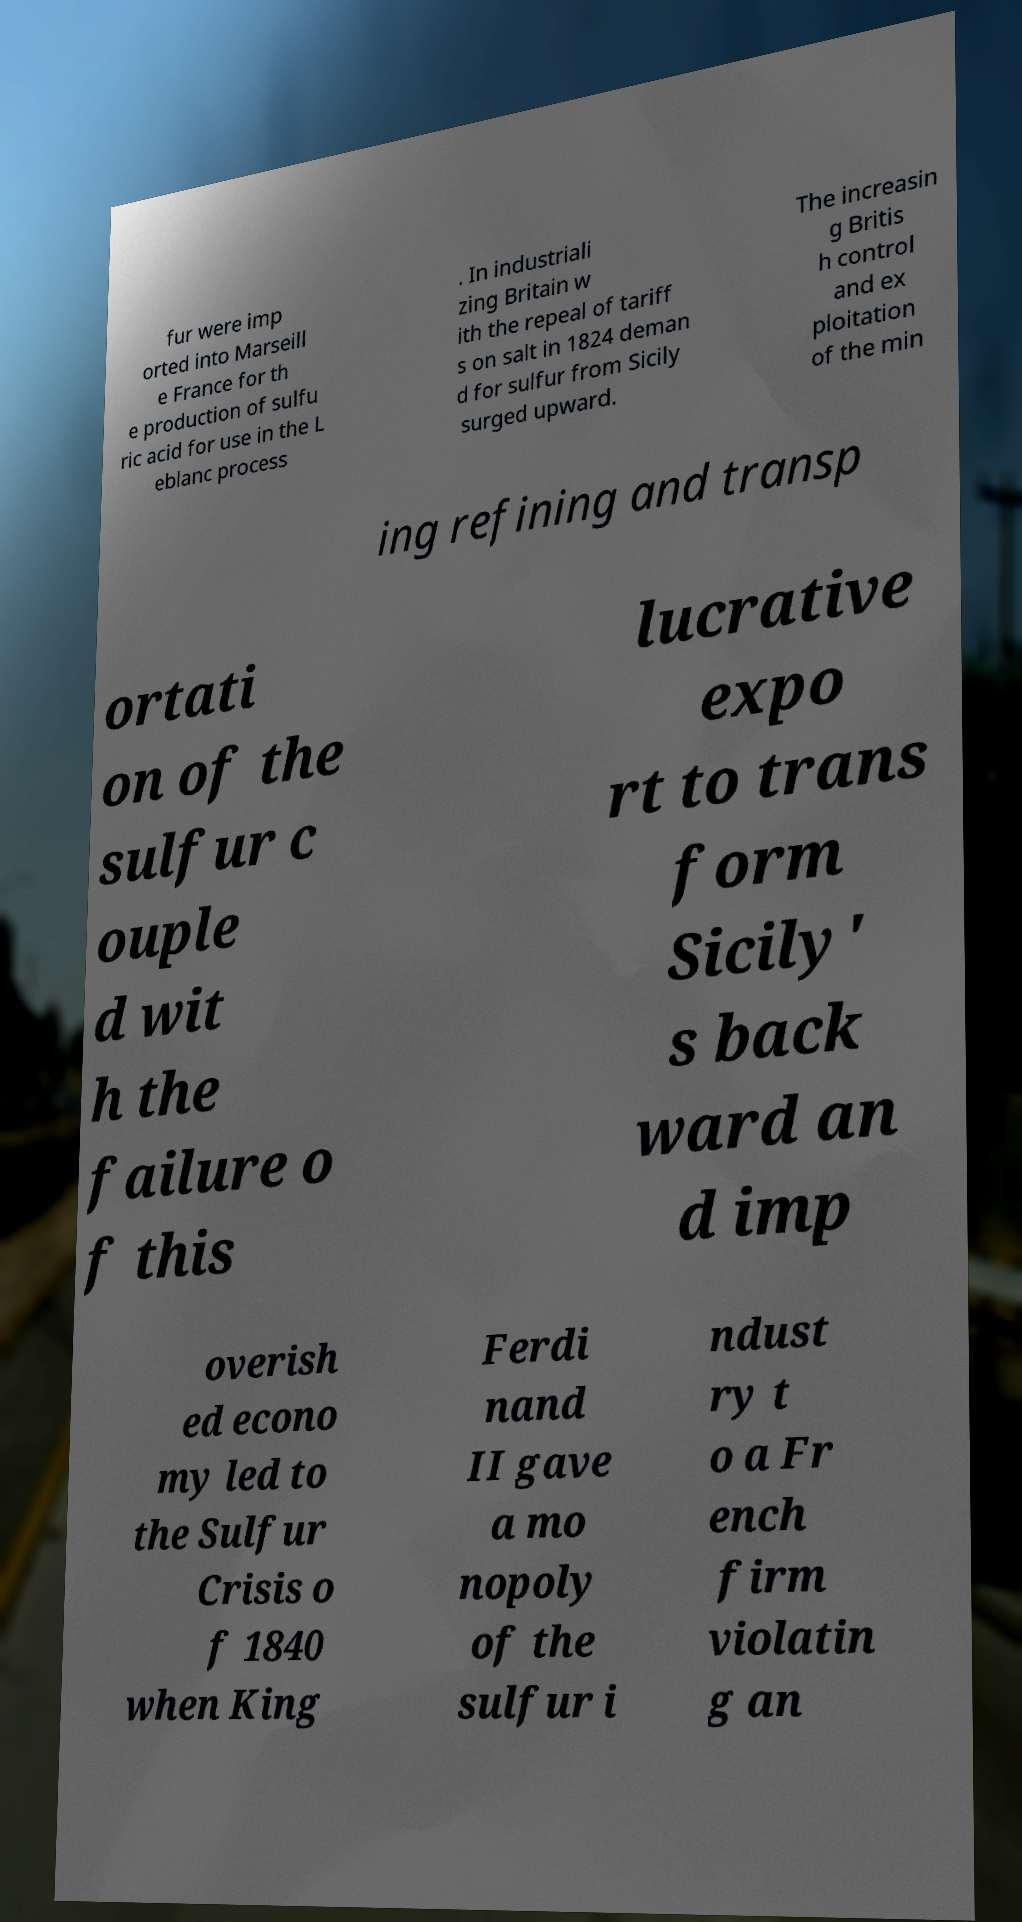Can you read and provide the text displayed in the image?This photo seems to have some interesting text. Can you extract and type it out for me? fur were imp orted into Marseill e France for th e production of sulfu ric acid for use in the L eblanc process . In industriali zing Britain w ith the repeal of tariff s on salt in 1824 deman d for sulfur from Sicily surged upward. The increasin g Britis h control and ex ploitation of the min ing refining and transp ortati on of the sulfur c ouple d wit h the failure o f this lucrative expo rt to trans form Sicily' s back ward an d imp overish ed econo my led to the Sulfur Crisis o f 1840 when King Ferdi nand II gave a mo nopoly of the sulfur i ndust ry t o a Fr ench firm violatin g an 